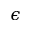Convert formula to latex. <formula><loc_0><loc_0><loc_500><loc_500>\epsilon</formula> 